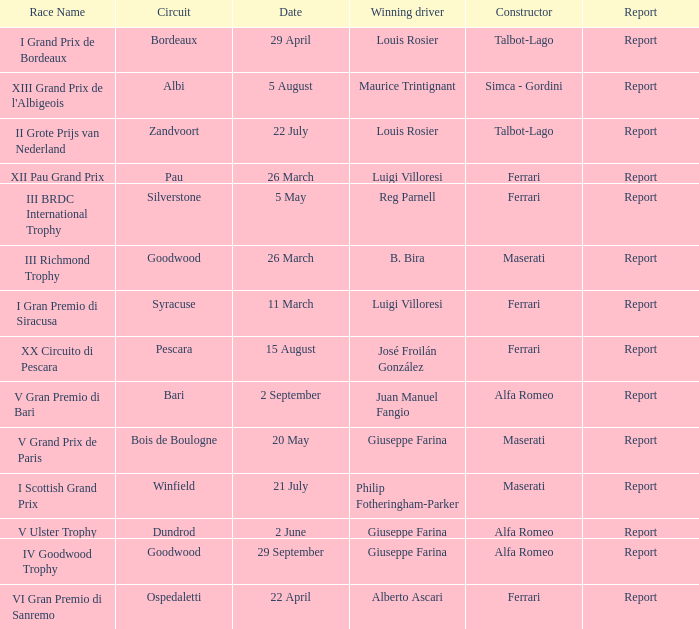Name the report for v grand prix de paris Report. 